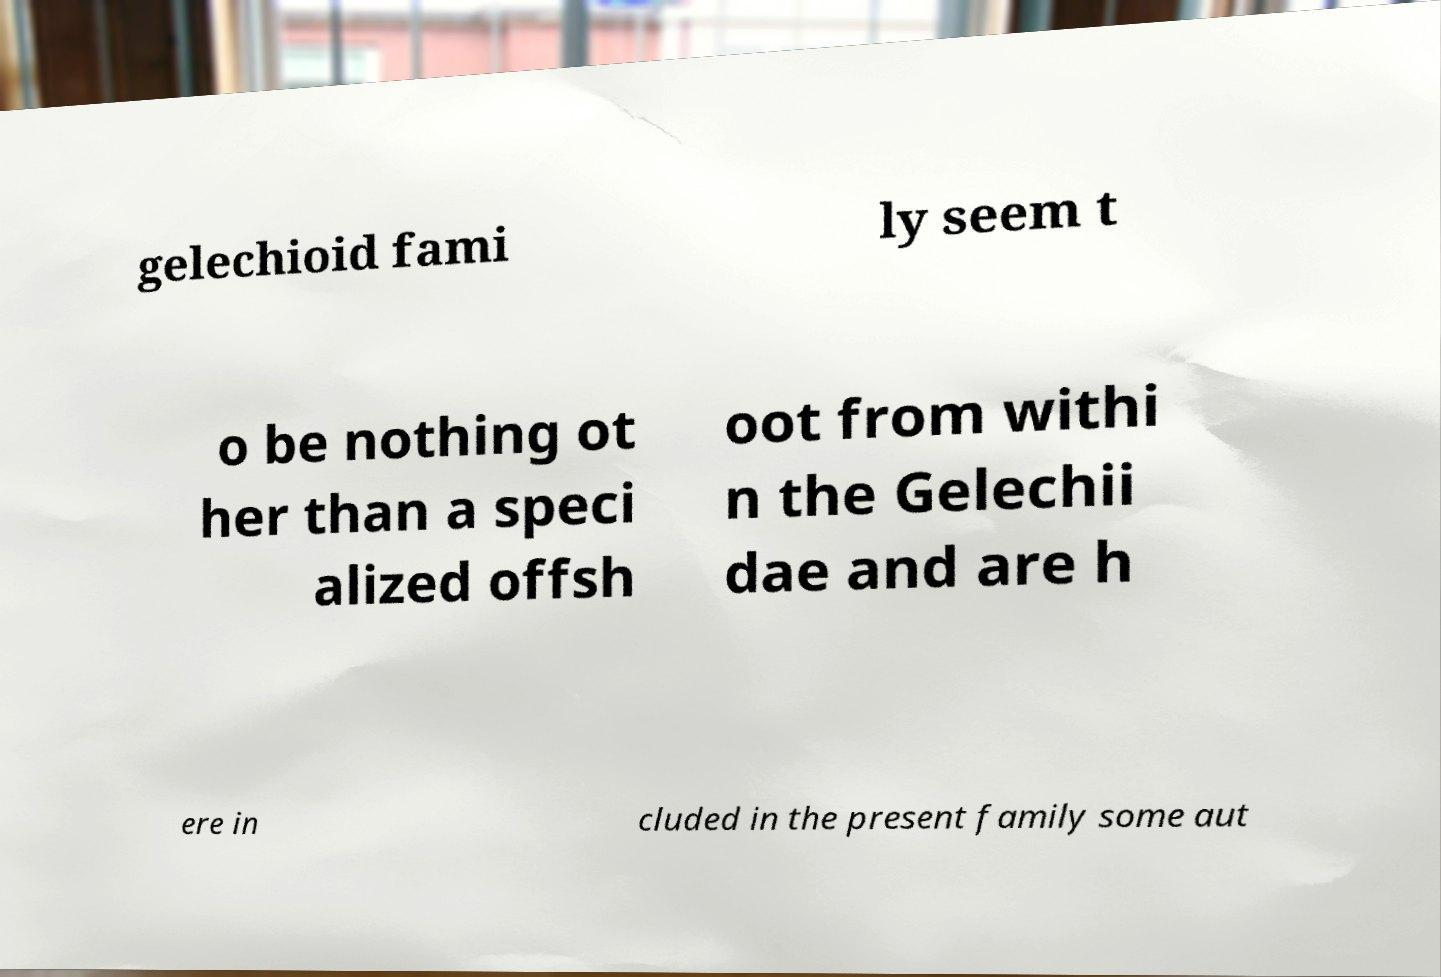Could you extract and type out the text from this image? gelechioid fami ly seem t o be nothing ot her than a speci alized offsh oot from withi n the Gelechii dae and are h ere in cluded in the present family some aut 